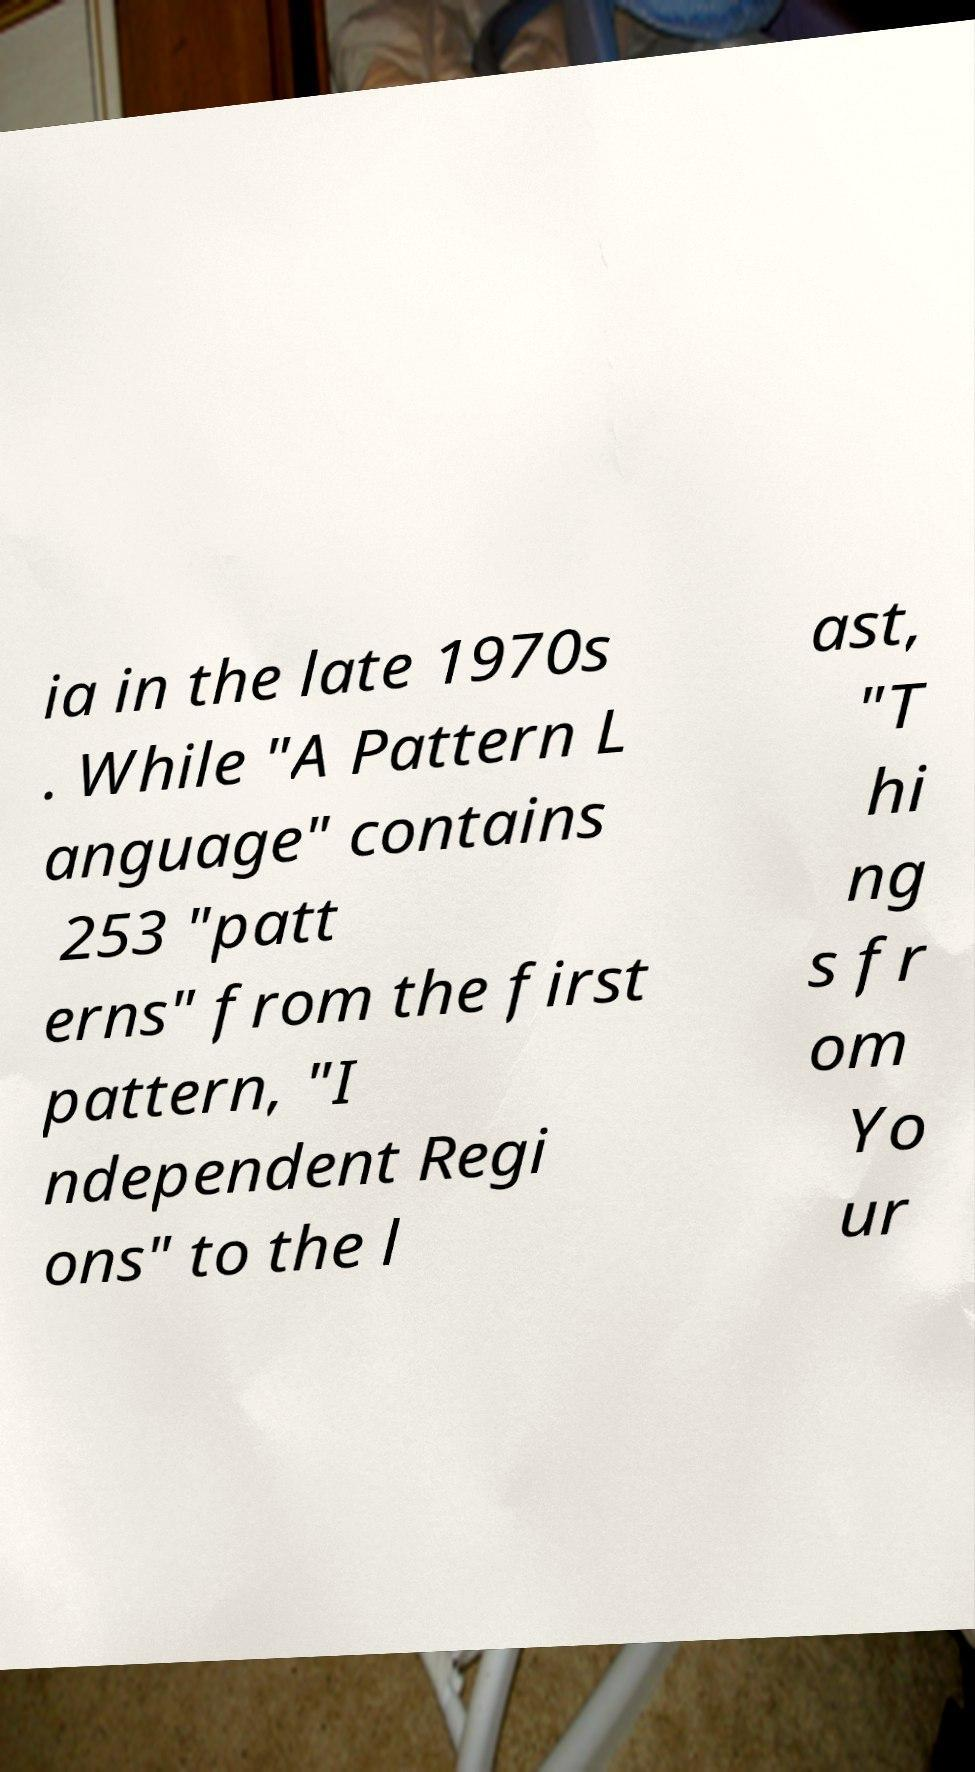I need the written content from this picture converted into text. Can you do that? ia in the late 1970s . While "A Pattern L anguage" contains 253 "patt erns" from the first pattern, "I ndependent Regi ons" to the l ast, "T hi ng s fr om Yo ur 